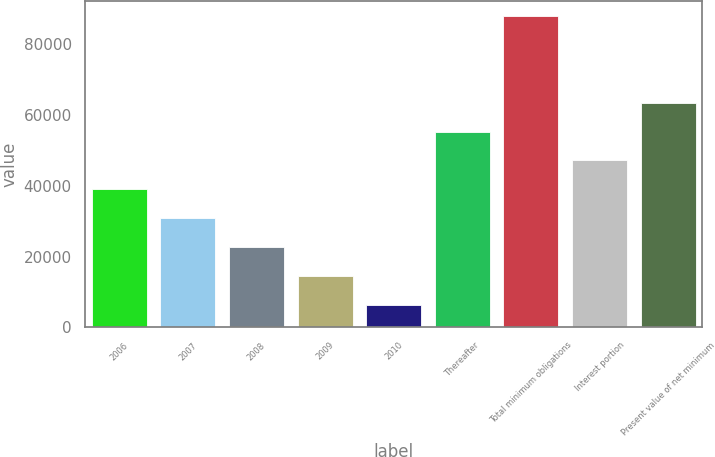<chart> <loc_0><loc_0><loc_500><loc_500><bar_chart><fcel>2006<fcel>2007<fcel>2008<fcel>2009<fcel>2010<fcel>Thereafter<fcel>Total minimum obligations<fcel>Interest portion<fcel>Present value of net minimum<nl><fcel>39033.4<fcel>30888.3<fcel>22743.2<fcel>14598.1<fcel>6453<fcel>55323.6<fcel>87904<fcel>47178.5<fcel>63468.7<nl></chart> 